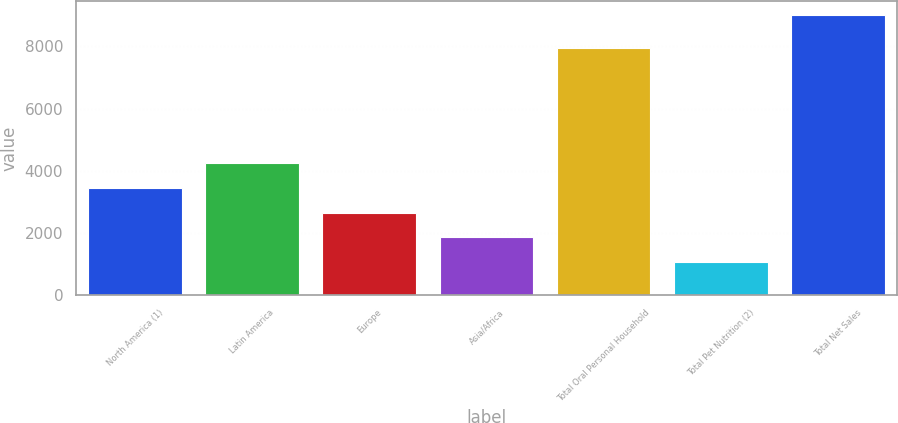Convert chart to OTSL. <chart><loc_0><loc_0><loc_500><loc_500><bar_chart><fcel>North America (1)<fcel>Latin America<fcel>Europe<fcel>Asia/Africa<fcel>Total Oral Personal Household<fcel>Total Pet Nutrition (2)<fcel>Total Net Sales<nl><fcel>3442.55<fcel>4237.1<fcel>2648<fcel>1853.45<fcel>7945.5<fcel>1058.9<fcel>9004.4<nl></chart> 